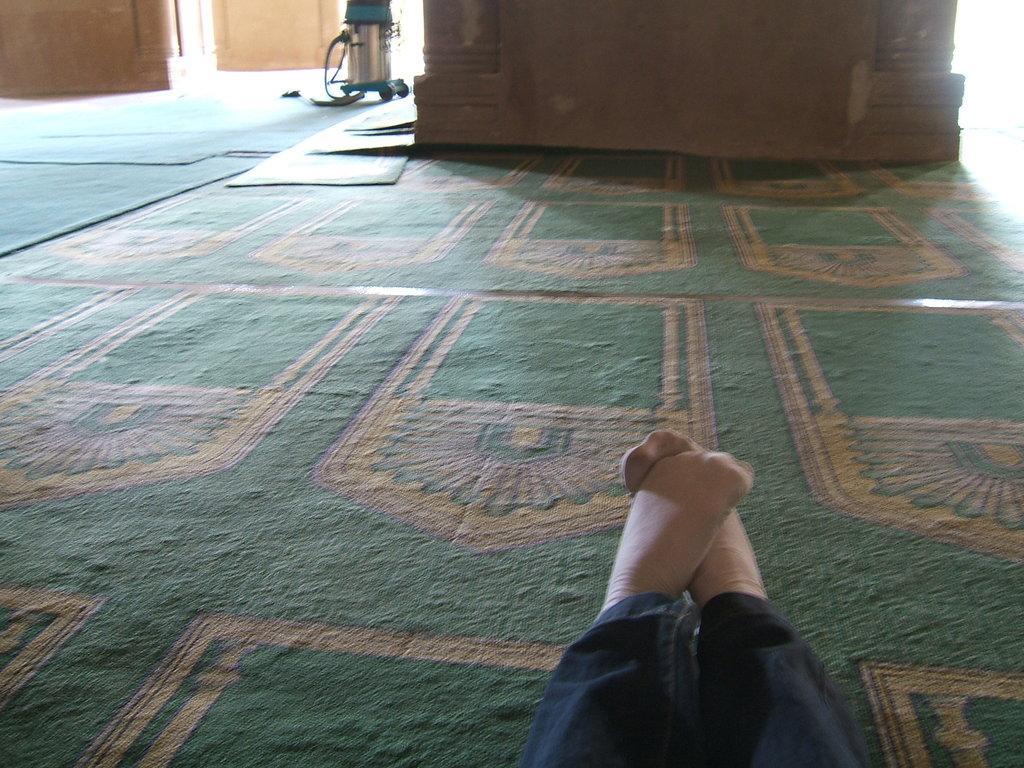Please provide a concise description of this image. In this picture there is a person with black jeans in the foreground. At the back there are pillars and there is a device. At the bottom there are mats. 